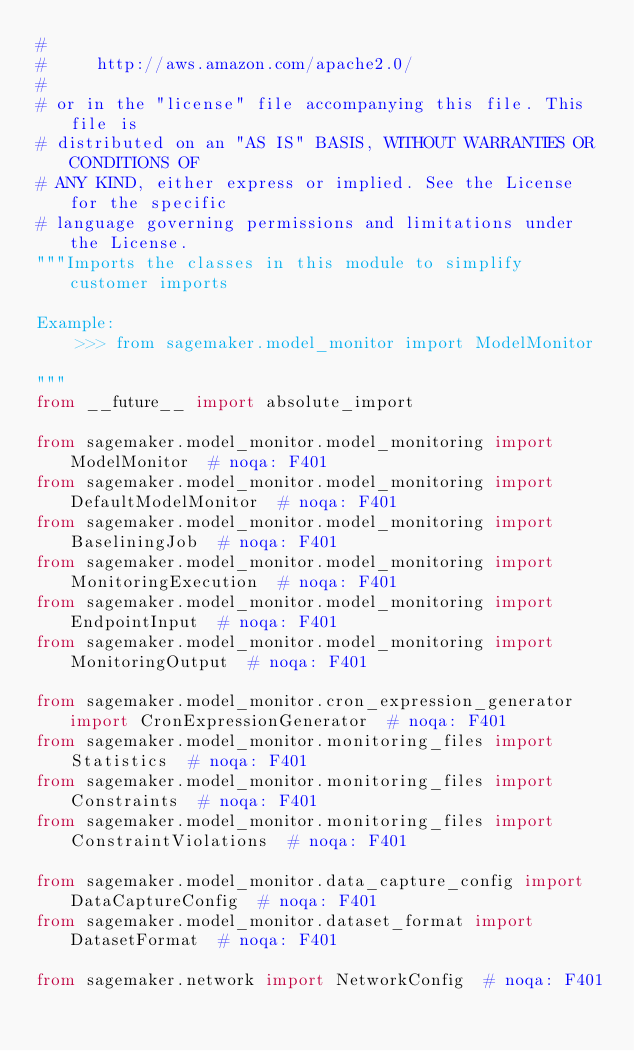<code> <loc_0><loc_0><loc_500><loc_500><_Python_>#
#     http://aws.amazon.com/apache2.0/
#
# or in the "license" file accompanying this file. This file is
# distributed on an "AS IS" BASIS, WITHOUT WARRANTIES OR CONDITIONS OF
# ANY KIND, either express or implied. See the License for the specific
# language governing permissions and limitations under the License.
"""Imports the classes in this module to simplify customer imports

Example:
    >>> from sagemaker.model_monitor import ModelMonitor

"""
from __future__ import absolute_import

from sagemaker.model_monitor.model_monitoring import ModelMonitor  # noqa: F401
from sagemaker.model_monitor.model_monitoring import DefaultModelMonitor  # noqa: F401
from sagemaker.model_monitor.model_monitoring import BaseliningJob  # noqa: F401
from sagemaker.model_monitor.model_monitoring import MonitoringExecution  # noqa: F401
from sagemaker.model_monitor.model_monitoring import EndpointInput  # noqa: F401
from sagemaker.model_monitor.model_monitoring import MonitoringOutput  # noqa: F401

from sagemaker.model_monitor.cron_expression_generator import CronExpressionGenerator  # noqa: F401
from sagemaker.model_monitor.monitoring_files import Statistics  # noqa: F401
from sagemaker.model_monitor.monitoring_files import Constraints  # noqa: F401
from sagemaker.model_monitor.monitoring_files import ConstraintViolations  # noqa: F401

from sagemaker.model_monitor.data_capture_config import DataCaptureConfig  # noqa: F401
from sagemaker.model_monitor.dataset_format import DatasetFormat  # noqa: F401

from sagemaker.network import NetworkConfig  # noqa: F401
</code> 